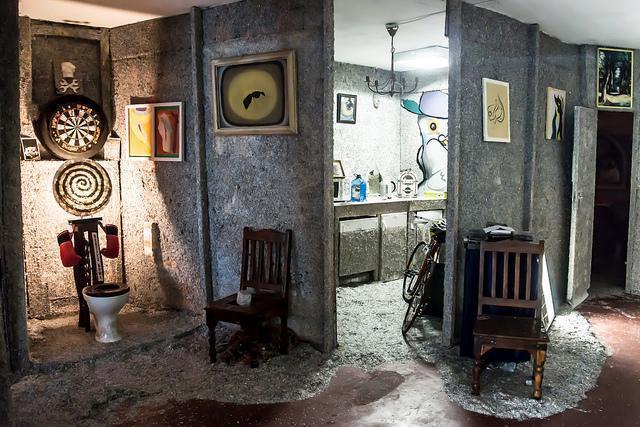Who most likely lives here?
Answer the question by selecting the correct answer among the 4 following choices.
Options: Eccentric, pilot, caveman, criminal. Eccentric. 